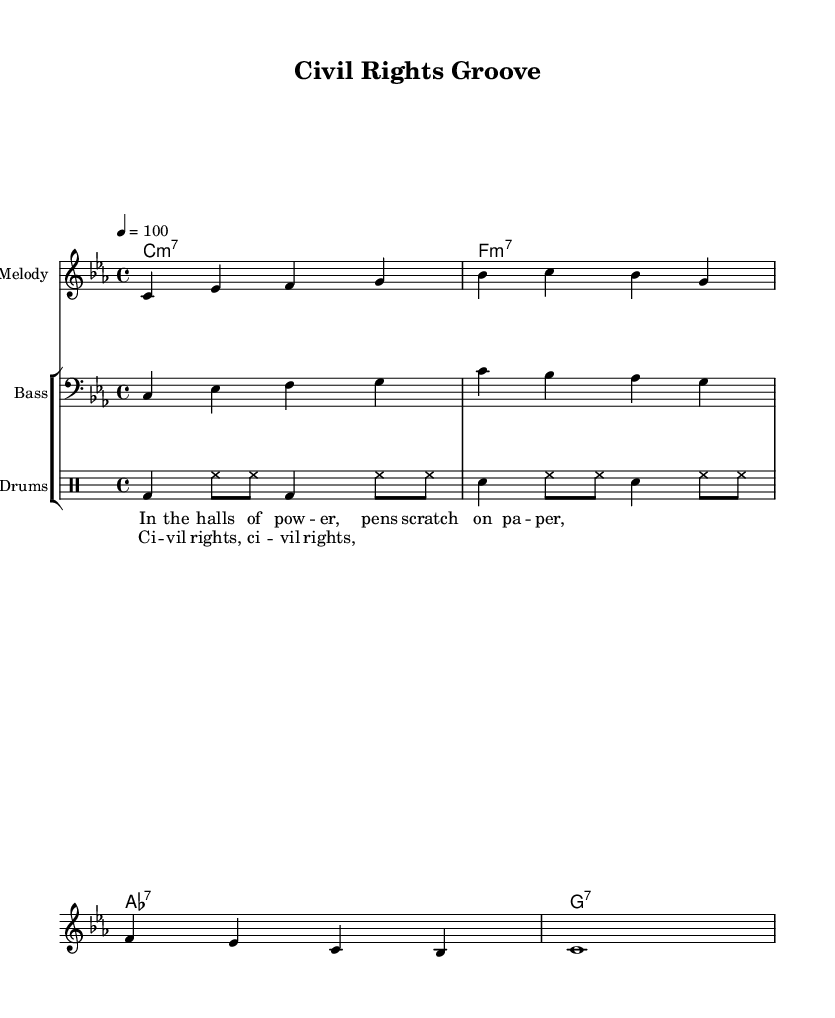What is the key signature of this music? The key signature indicates C minor, which contains three flats (B♭, E♭, A♭). This is shown at the beginning of the staff.
Answer: C minor What is the time signature of the piece? The time signature is found at the start of the score. In this case, it is 4/4, meaning there are four beats in each measure and a quarter note receives one beat.
Answer: 4/4 What is the tempo marking of the composition? The tempo is indicated as 4 = 100, meaning that the quarter note should be played at a speed of 100 beats per minute. This sets the pace for the performance.
Answer: 100 What instruments are included in the score? The score features a melody staff, a bass staff, and a drum staff; the notation for each is visible in the instrument names above their respective staves.
Answer: Melody, Bass, Drums How many measures are in the melody? Counting the measures in the melody line, which is governed by the vertical bar lines, we find there are four complete measures represented in the notation.
Answer: 4 What is the main theme of the lyrics in the chorus? The chorus lyric "Civil rights, civil rights" reflects the focus on social justice issues related to the Civil Rights Movement, connecting with the historical context of the piece.
Answer: Civil rights Which chord appears most frequently in the progression? Looking at the chord progression provided, C minor 7 appears first and is then followed by other chords, but it is the foundation, indicated at the beginning and influences the overall mood.
Answer: C minor 7 